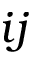Convert formula to latex. <formula><loc_0><loc_0><loc_500><loc_500>i j</formula> 